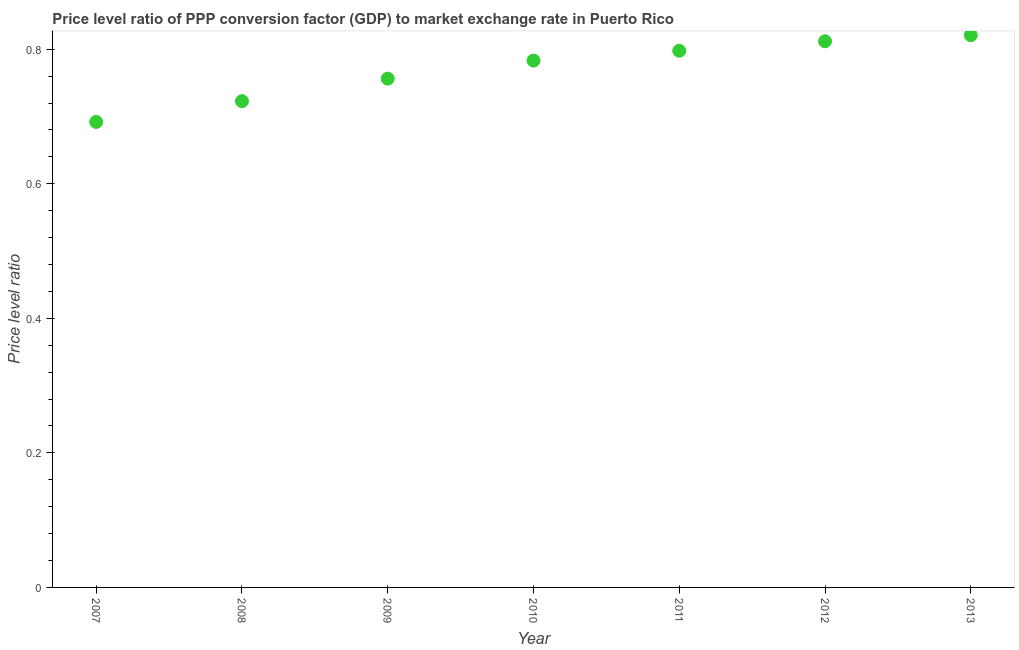What is the price level ratio in 2008?
Make the answer very short. 0.72. Across all years, what is the maximum price level ratio?
Your response must be concise. 0.82. Across all years, what is the minimum price level ratio?
Offer a very short reply. 0.69. In which year was the price level ratio maximum?
Keep it short and to the point. 2013. In which year was the price level ratio minimum?
Provide a short and direct response. 2007. What is the sum of the price level ratio?
Provide a short and direct response. 5.38. What is the difference between the price level ratio in 2008 and 2010?
Give a very brief answer. -0.06. What is the average price level ratio per year?
Ensure brevity in your answer.  0.77. What is the median price level ratio?
Give a very brief answer. 0.78. Do a majority of the years between 2010 and 2008 (inclusive) have price level ratio greater than 0.56 ?
Offer a terse response. No. What is the ratio of the price level ratio in 2007 to that in 2010?
Make the answer very short. 0.88. Is the difference between the price level ratio in 2008 and 2013 greater than the difference between any two years?
Provide a succinct answer. No. What is the difference between the highest and the second highest price level ratio?
Ensure brevity in your answer.  0.01. Is the sum of the price level ratio in 2010 and 2012 greater than the maximum price level ratio across all years?
Make the answer very short. Yes. What is the difference between the highest and the lowest price level ratio?
Your response must be concise. 0.13. How many years are there in the graph?
Keep it short and to the point. 7. What is the difference between two consecutive major ticks on the Y-axis?
Keep it short and to the point. 0.2. What is the title of the graph?
Give a very brief answer. Price level ratio of PPP conversion factor (GDP) to market exchange rate in Puerto Rico. What is the label or title of the Y-axis?
Offer a terse response. Price level ratio. What is the Price level ratio in 2007?
Your response must be concise. 0.69. What is the Price level ratio in 2008?
Provide a succinct answer. 0.72. What is the Price level ratio in 2009?
Ensure brevity in your answer.  0.76. What is the Price level ratio in 2010?
Offer a very short reply. 0.78. What is the Price level ratio in 2011?
Your answer should be compact. 0.8. What is the Price level ratio in 2012?
Provide a succinct answer. 0.81. What is the Price level ratio in 2013?
Your answer should be very brief. 0.82. What is the difference between the Price level ratio in 2007 and 2008?
Ensure brevity in your answer.  -0.03. What is the difference between the Price level ratio in 2007 and 2009?
Provide a short and direct response. -0.06. What is the difference between the Price level ratio in 2007 and 2010?
Keep it short and to the point. -0.09. What is the difference between the Price level ratio in 2007 and 2011?
Offer a very short reply. -0.11. What is the difference between the Price level ratio in 2007 and 2012?
Give a very brief answer. -0.12. What is the difference between the Price level ratio in 2007 and 2013?
Make the answer very short. -0.13. What is the difference between the Price level ratio in 2008 and 2009?
Your response must be concise. -0.03. What is the difference between the Price level ratio in 2008 and 2010?
Your answer should be very brief. -0.06. What is the difference between the Price level ratio in 2008 and 2011?
Provide a succinct answer. -0.07. What is the difference between the Price level ratio in 2008 and 2012?
Your response must be concise. -0.09. What is the difference between the Price level ratio in 2008 and 2013?
Your response must be concise. -0.1. What is the difference between the Price level ratio in 2009 and 2010?
Ensure brevity in your answer.  -0.03. What is the difference between the Price level ratio in 2009 and 2011?
Offer a terse response. -0.04. What is the difference between the Price level ratio in 2009 and 2012?
Offer a very short reply. -0.06. What is the difference between the Price level ratio in 2009 and 2013?
Provide a short and direct response. -0.06. What is the difference between the Price level ratio in 2010 and 2011?
Your response must be concise. -0.01. What is the difference between the Price level ratio in 2010 and 2012?
Your answer should be very brief. -0.03. What is the difference between the Price level ratio in 2010 and 2013?
Your answer should be very brief. -0.04. What is the difference between the Price level ratio in 2011 and 2012?
Make the answer very short. -0.01. What is the difference between the Price level ratio in 2011 and 2013?
Your answer should be compact. -0.02. What is the difference between the Price level ratio in 2012 and 2013?
Make the answer very short. -0.01. What is the ratio of the Price level ratio in 2007 to that in 2009?
Give a very brief answer. 0.92. What is the ratio of the Price level ratio in 2007 to that in 2010?
Your answer should be compact. 0.88. What is the ratio of the Price level ratio in 2007 to that in 2011?
Provide a short and direct response. 0.87. What is the ratio of the Price level ratio in 2007 to that in 2012?
Give a very brief answer. 0.85. What is the ratio of the Price level ratio in 2007 to that in 2013?
Offer a terse response. 0.84. What is the ratio of the Price level ratio in 2008 to that in 2009?
Give a very brief answer. 0.96. What is the ratio of the Price level ratio in 2008 to that in 2010?
Provide a succinct answer. 0.92. What is the ratio of the Price level ratio in 2008 to that in 2011?
Give a very brief answer. 0.91. What is the ratio of the Price level ratio in 2008 to that in 2012?
Provide a succinct answer. 0.89. What is the ratio of the Price level ratio in 2008 to that in 2013?
Offer a terse response. 0.88. What is the ratio of the Price level ratio in 2009 to that in 2011?
Your answer should be compact. 0.95. What is the ratio of the Price level ratio in 2009 to that in 2012?
Offer a very short reply. 0.93. What is the ratio of the Price level ratio in 2009 to that in 2013?
Make the answer very short. 0.92. What is the ratio of the Price level ratio in 2010 to that in 2011?
Your answer should be compact. 0.98. What is the ratio of the Price level ratio in 2010 to that in 2013?
Keep it short and to the point. 0.95. What is the ratio of the Price level ratio in 2011 to that in 2013?
Offer a terse response. 0.97. 